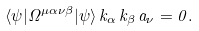Convert formula to latex. <formula><loc_0><loc_0><loc_500><loc_500>\langle \psi | \Omega ^ { \mu \alpha \nu \beta } | \psi \rangle \, k _ { \alpha } \, k _ { \beta } \, a _ { \nu } = 0 .</formula> 